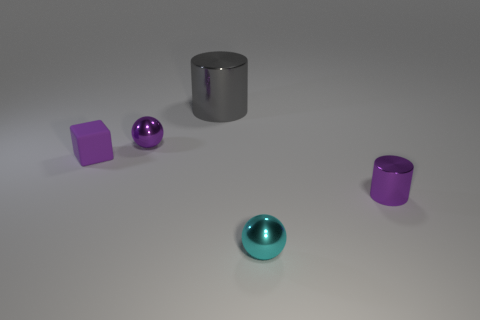Add 1 small purple rubber objects. How many objects exist? 6 Subtract all spheres. How many objects are left? 3 Add 4 shiny objects. How many shiny objects are left? 8 Add 2 blue rubber spheres. How many blue rubber spheres exist? 2 Subtract 0 blue balls. How many objects are left? 5 Subtract all tiny metal things. Subtract all small green metallic blocks. How many objects are left? 2 